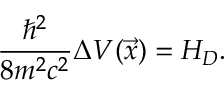<formula> <loc_0><loc_0><loc_500><loc_500>\frac { \hbar { ^ } { 2 } } { 8 m ^ { 2 } c ^ { 2 } } \Delta V ( \vec { x } ) = H _ { D } .</formula> 